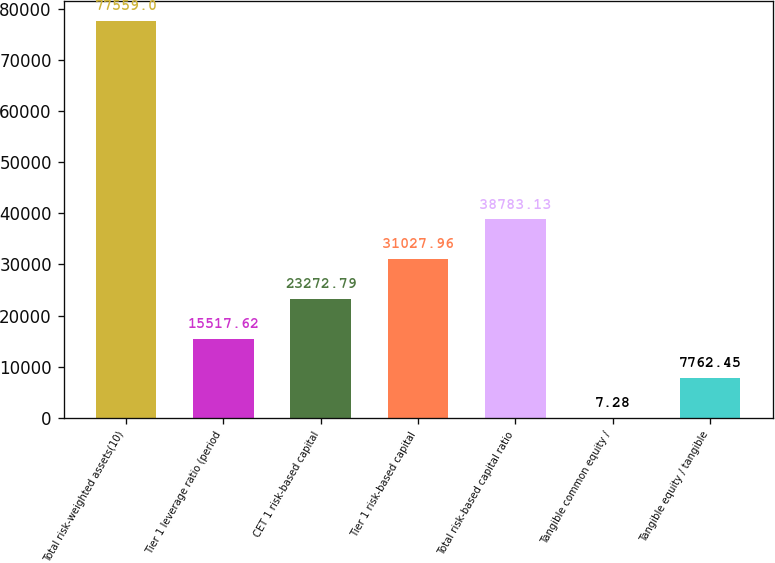<chart> <loc_0><loc_0><loc_500><loc_500><bar_chart><fcel>Total risk-weighted assets(10)<fcel>Tier 1 leverage ratio (period<fcel>CET 1 risk-based capital<fcel>Tier 1 risk-based capital<fcel>Total risk-based capital ratio<fcel>Tangible common equity /<fcel>Tangible equity / tangible<nl><fcel>77559<fcel>15517.6<fcel>23272.8<fcel>31028<fcel>38783.1<fcel>7.28<fcel>7762.45<nl></chart> 